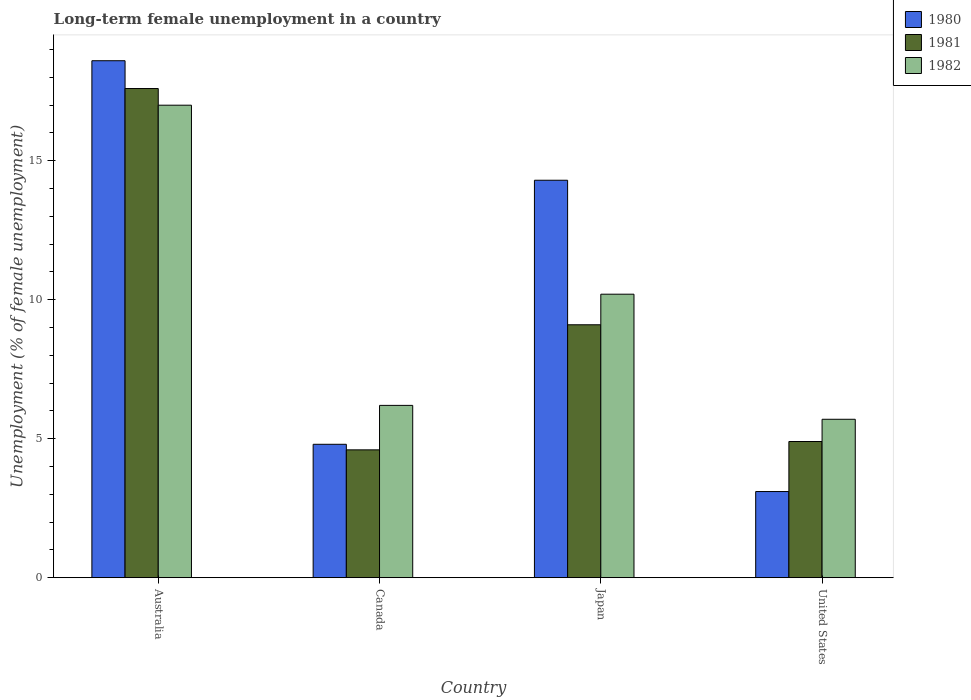How many groups of bars are there?
Your response must be concise. 4. Are the number of bars on each tick of the X-axis equal?
Your answer should be compact. Yes. How many bars are there on the 2nd tick from the left?
Provide a succinct answer. 3. What is the percentage of long-term unemployed female population in 1980 in United States?
Your answer should be very brief. 3.1. Across all countries, what is the maximum percentage of long-term unemployed female population in 1982?
Your answer should be very brief. 17. Across all countries, what is the minimum percentage of long-term unemployed female population in 1980?
Provide a short and direct response. 3.1. In which country was the percentage of long-term unemployed female population in 1982 minimum?
Provide a succinct answer. United States. What is the total percentage of long-term unemployed female population in 1981 in the graph?
Keep it short and to the point. 36.2. What is the difference between the percentage of long-term unemployed female population in 1982 in Canada and that in Japan?
Provide a short and direct response. -4. What is the difference between the percentage of long-term unemployed female population in 1982 in Canada and the percentage of long-term unemployed female population in 1980 in Australia?
Your response must be concise. -12.4. What is the average percentage of long-term unemployed female population in 1981 per country?
Provide a succinct answer. 9.05. What is the difference between the percentage of long-term unemployed female population of/in 1981 and percentage of long-term unemployed female population of/in 1980 in Japan?
Give a very brief answer. -5.2. What is the ratio of the percentage of long-term unemployed female population in 1981 in Australia to that in Japan?
Your response must be concise. 1.93. Is the difference between the percentage of long-term unemployed female population in 1981 in Canada and Japan greater than the difference between the percentage of long-term unemployed female population in 1980 in Canada and Japan?
Your response must be concise. Yes. What is the difference between the highest and the second highest percentage of long-term unemployed female population in 1982?
Offer a terse response. 6.8. What is the difference between the highest and the lowest percentage of long-term unemployed female population in 1981?
Provide a succinct answer. 13. What does the 3rd bar from the left in United States represents?
Offer a very short reply. 1982. What does the 1st bar from the right in United States represents?
Your answer should be very brief. 1982. What is the difference between two consecutive major ticks on the Y-axis?
Provide a short and direct response. 5. Are the values on the major ticks of Y-axis written in scientific E-notation?
Ensure brevity in your answer.  No. Does the graph contain grids?
Give a very brief answer. No. Where does the legend appear in the graph?
Your response must be concise. Top right. How many legend labels are there?
Offer a very short reply. 3. How are the legend labels stacked?
Provide a short and direct response. Vertical. What is the title of the graph?
Provide a succinct answer. Long-term female unemployment in a country. Does "1980" appear as one of the legend labels in the graph?
Keep it short and to the point. Yes. What is the label or title of the Y-axis?
Provide a succinct answer. Unemployment (% of female unemployment). What is the Unemployment (% of female unemployment) of 1980 in Australia?
Keep it short and to the point. 18.6. What is the Unemployment (% of female unemployment) in 1981 in Australia?
Provide a succinct answer. 17.6. What is the Unemployment (% of female unemployment) of 1982 in Australia?
Offer a terse response. 17. What is the Unemployment (% of female unemployment) in 1980 in Canada?
Offer a terse response. 4.8. What is the Unemployment (% of female unemployment) of 1981 in Canada?
Your answer should be compact. 4.6. What is the Unemployment (% of female unemployment) of 1982 in Canada?
Give a very brief answer. 6.2. What is the Unemployment (% of female unemployment) in 1980 in Japan?
Offer a very short reply. 14.3. What is the Unemployment (% of female unemployment) of 1981 in Japan?
Offer a very short reply. 9.1. What is the Unemployment (% of female unemployment) in 1982 in Japan?
Ensure brevity in your answer.  10.2. What is the Unemployment (% of female unemployment) in 1980 in United States?
Make the answer very short. 3.1. What is the Unemployment (% of female unemployment) of 1981 in United States?
Provide a short and direct response. 4.9. What is the Unemployment (% of female unemployment) in 1982 in United States?
Ensure brevity in your answer.  5.7. Across all countries, what is the maximum Unemployment (% of female unemployment) of 1980?
Provide a succinct answer. 18.6. Across all countries, what is the maximum Unemployment (% of female unemployment) of 1981?
Offer a terse response. 17.6. Across all countries, what is the minimum Unemployment (% of female unemployment) of 1980?
Offer a very short reply. 3.1. Across all countries, what is the minimum Unemployment (% of female unemployment) in 1981?
Offer a very short reply. 4.6. Across all countries, what is the minimum Unemployment (% of female unemployment) in 1982?
Your answer should be very brief. 5.7. What is the total Unemployment (% of female unemployment) of 1980 in the graph?
Provide a succinct answer. 40.8. What is the total Unemployment (% of female unemployment) of 1981 in the graph?
Offer a terse response. 36.2. What is the total Unemployment (% of female unemployment) in 1982 in the graph?
Offer a very short reply. 39.1. What is the difference between the Unemployment (% of female unemployment) of 1981 in Australia and that in Canada?
Offer a very short reply. 13. What is the difference between the Unemployment (% of female unemployment) in 1981 in Australia and that in Japan?
Your response must be concise. 8.5. What is the difference between the Unemployment (% of female unemployment) of 1980 in Australia and that in United States?
Provide a succinct answer. 15.5. What is the difference between the Unemployment (% of female unemployment) of 1981 in Canada and that in United States?
Provide a succinct answer. -0.3. What is the difference between the Unemployment (% of female unemployment) of 1980 in Australia and the Unemployment (% of female unemployment) of 1981 in United States?
Provide a succinct answer. 13.7. What is the difference between the Unemployment (% of female unemployment) of 1980 in Australia and the Unemployment (% of female unemployment) of 1982 in United States?
Your answer should be compact. 12.9. What is the difference between the Unemployment (% of female unemployment) in 1980 in Canada and the Unemployment (% of female unemployment) in 1981 in Japan?
Your answer should be compact. -4.3. What is the difference between the Unemployment (% of female unemployment) in 1980 in Canada and the Unemployment (% of female unemployment) in 1982 in United States?
Provide a succinct answer. -0.9. What is the difference between the Unemployment (% of female unemployment) of 1981 in Canada and the Unemployment (% of female unemployment) of 1982 in United States?
Provide a succinct answer. -1.1. What is the average Unemployment (% of female unemployment) of 1981 per country?
Your answer should be compact. 9.05. What is the average Unemployment (% of female unemployment) in 1982 per country?
Provide a short and direct response. 9.78. What is the difference between the Unemployment (% of female unemployment) of 1980 and Unemployment (% of female unemployment) of 1982 in Australia?
Your answer should be compact. 1.6. What is the difference between the Unemployment (% of female unemployment) of 1981 and Unemployment (% of female unemployment) of 1982 in Australia?
Your response must be concise. 0.6. What is the difference between the Unemployment (% of female unemployment) in 1980 and Unemployment (% of female unemployment) in 1981 in Canada?
Make the answer very short. 0.2. What is the difference between the Unemployment (% of female unemployment) of 1980 and Unemployment (% of female unemployment) of 1982 in Canada?
Provide a succinct answer. -1.4. What is the difference between the Unemployment (% of female unemployment) of 1980 and Unemployment (% of female unemployment) of 1982 in Japan?
Keep it short and to the point. 4.1. What is the difference between the Unemployment (% of female unemployment) in 1980 and Unemployment (% of female unemployment) in 1981 in United States?
Provide a short and direct response. -1.8. What is the difference between the Unemployment (% of female unemployment) of 1980 and Unemployment (% of female unemployment) of 1982 in United States?
Your response must be concise. -2.6. What is the difference between the Unemployment (% of female unemployment) in 1981 and Unemployment (% of female unemployment) in 1982 in United States?
Your answer should be very brief. -0.8. What is the ratio of the Unemployment (% of female unemployment) of 1980 in Australia to that in Canada?
Give a very brief answer. 3.88. What is the ratio of the Unemployment (% of female unemployment) of 1981 in Australia to that in Canada?
Your answer should be compact. 3.83. What is the ratio of the Unemployment (% of female unemployment) in 1982 in Australia to that in Canada?
Give a very brief answer. 2.74. What is the ratio of the Unemployment (% of female unemployment) in 1980 in Australia to that in Japan?
Keep it short and to the point. 1.3. What is the ratio of the Unemployment (% of female unemployment) of 1981 in Australia to that in Japan?
Offer a very short reply. 1.93. What is the ratio of the Unemployment (% of female unemployment) in 1982 in Australia to that in Japan?
Keep it short and to the point. 1.67. What is the ratio of the Unemployment (% of female unemployment) of 1981 in Australia to that in United States?
Provide a succinct answer. 3.59. What is the ratio of the Unemployment (% of female unemployment) of 1982 in Australia to that in United States?
Your answer should be compact. 2.98. What is the ratio of the Unemployment (% of female unemployment) of 1980 in Canada to that in Japan?
Offer a very short reply. 0.34. What is the ratio of the Unemployment (% of female unemployment) of 1981 in Canada to that in Japan?
Offer a very short reply. 0.51. What is the ratio of the Unemployment (% of female unemployment) of 1982 in Canada to that in Japan?
Make the answer very short. 0.61. What is the ratio of the Unemployment (% of female unemployment) of 1980 in Canada to that in United States?
Ensure brevity in your answer.  1.55. What is the ratio of the Unemployment (% of female unemployment) of 1981 in Canada to that in United States?
Make the answer very short. 0.94. What is the ratio of the Unemployment (% of female unemployment) of 1982 in Canada to that in United States?
Provide a succinct answer. 1.09. What is the ratio of the Unemployment (% of female unemployment) in 1980 in Japan to that in United States?
Give a very brief answer. 4.61. What is the ratio of the Unemployment (% of female unemployment) of 1981 in Japan to that in United States?
Your response must be concise. 1.86. What is the ratio of the Unemployment (% of female unemployment) in 1982 in Japan to that in United States?
Your response must be concise. 1.79. What is the difference between the highest and the second highest Unemployment (% of female unemployment) in 1981?
Offer a terse response. 8.5. What is the difference between the highest and the lowest Unemployment (% of female unemployment) in 1981?
Your response must be concise. 13. 